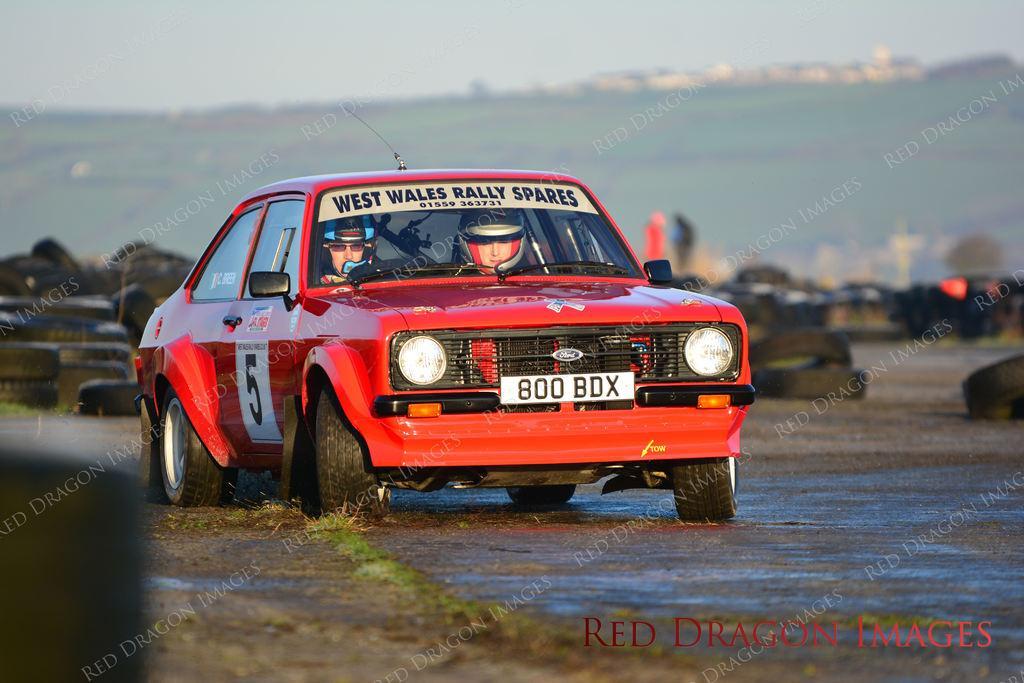In one or two sentences, can you explain what this image depicts? In the picture we can see a car on the path, the car is red in color with two people inside it and in the background, we can see some tires are placed on the path, in the background, we can see a hill with a grass on it and some houses and we can also see a sky. 